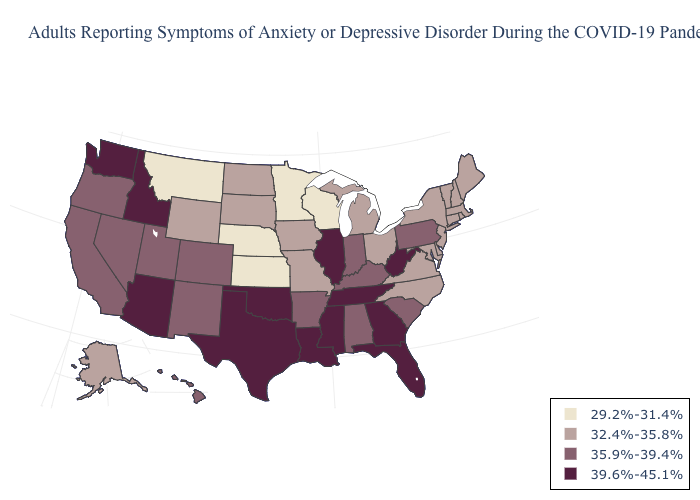What is the value of Massachusetts?
Concise answer only. 32.4%-35.8%. Name the states that have a value in the range 32.4%-35.8%?
Be succinct. Alaska, Connecticut, Delaware, Iowa, Maine, Maryland, Massachusetts, Michigan, Missouri, New Hampshire, New Jersey, New York, North Carolina, North Dakota, Ohio, Rhode Island, South Dakota, Vermont, Virginia, Wyoming. Name the states that have a value in the range 35.9%-39.4%?
Be succinct. Alabama, Arkansas, California, Colorado, Hawaii, Indiana, Kentucky, Nevada, New Mexico, Oregon, Pennsylvania, South Carolina, Utah. Name the states that have a value in the range 35.9%-39.4%?
Concise answer only. Alabama, Arkansas, California, Colorado, Hawaii, Indiana, Kentucky, Nevada, New Mexico, Oregon, Pennsylvania, South Carolina, Utah. Does Georgia have the highest value in the South?
Quick response, please. Yes. What is the lowest value in the South?
Quick response, please. 32.4%-35.8%. What is the value of Louisiana?
Give a very brief answer. 39.6%-45.1%. Name the states that have a value in the range 32.4%-35.8%?
Quick response, please. Alaska, Connecticut, Delaware, Iowa, Maine, Maryland, Massachusetts, Michigan, Missouri, New Hampshire, New Jersey, New York, North Carolina, North Dakota, Ohio, Rhode Island, South Dakota, Vermont, Virginia, Wyoming. What is the value of North Dakota?
Quick response, please. 32.4%-35.8%. Name the states that have a value in the range 32.4%-35.8%?
Concise answer only. Alaska, Connecticut, Delaware, Iowa, Maine, Maryland, Massachusetts, Michigan, Missouri, New Hampshire, New Jersey, New York, North Carolina, North Dakota, Ohio, Rhode Island, South Dakota, Vermont, Virginia, Wyoming. What is the value of Maine?
Concise answer only. 32.4%-35.8%. Which states have the highest value in the USA?
Concise answer only. Arizona, Florida, Georgia, Idaho, Illinois, Louisiana, Mississippi, Oklahoma, Tennessee, Texas, Washington, West Virginia. Is the legend a continuous bar?
Be succinct. No. What is the lowest value in the South?
Quick response, please. 32.4%-35.8%. Does Virginia have the same value as Pennsylvania?
Be succinct. No. 